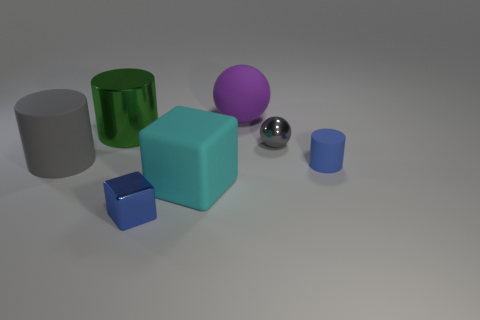Are there any patterns or textures on the objects? The objects in the image have a smooth, matte finish with no visible patterns or textures. Each object reflects light in a way that highlights its solid color and clean lines. 